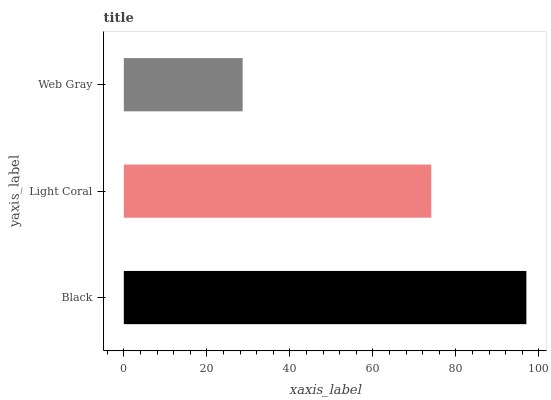Is Web Gray the minimum?
Answer yes or no. Yes. Is Black the maximum?
Answer yes or no. Yes. Is Light Coral the minimum?
Answer yes or no. No. Is Light Coral the maximum?
Answer yes or no. No. Is Black greater than Light Coral?
Answer yes or no. Yes. Is Light Coral less than Black?
Answer yes or no. Yes. Is Light Coral greater than Black?
Answer yes or no. No. Is Black less than Light Coral?
Answer yes or no. No. Is Light Coral the high median?
Answer yes or no. Yes. Is Light Coral the low median?
Answer yes or no. Yes. Is Black the high median?
Answer yes or no. No. Is Black the low median?
Answer yes or no. No. 